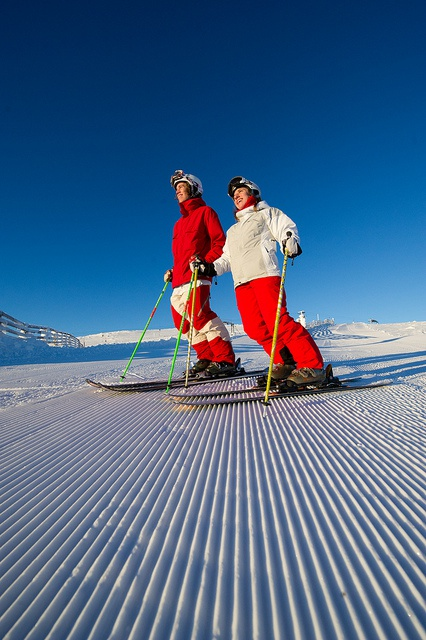Describe the objects in this image and their specific colors. I can see people in navy, red, tan, black, and beige tones, people in navy, red, black, maroon, and brown tones, skis in navy, black, gray, and darkgray tones, and skis in navy, black, gray, and darkgray tones in this image. 